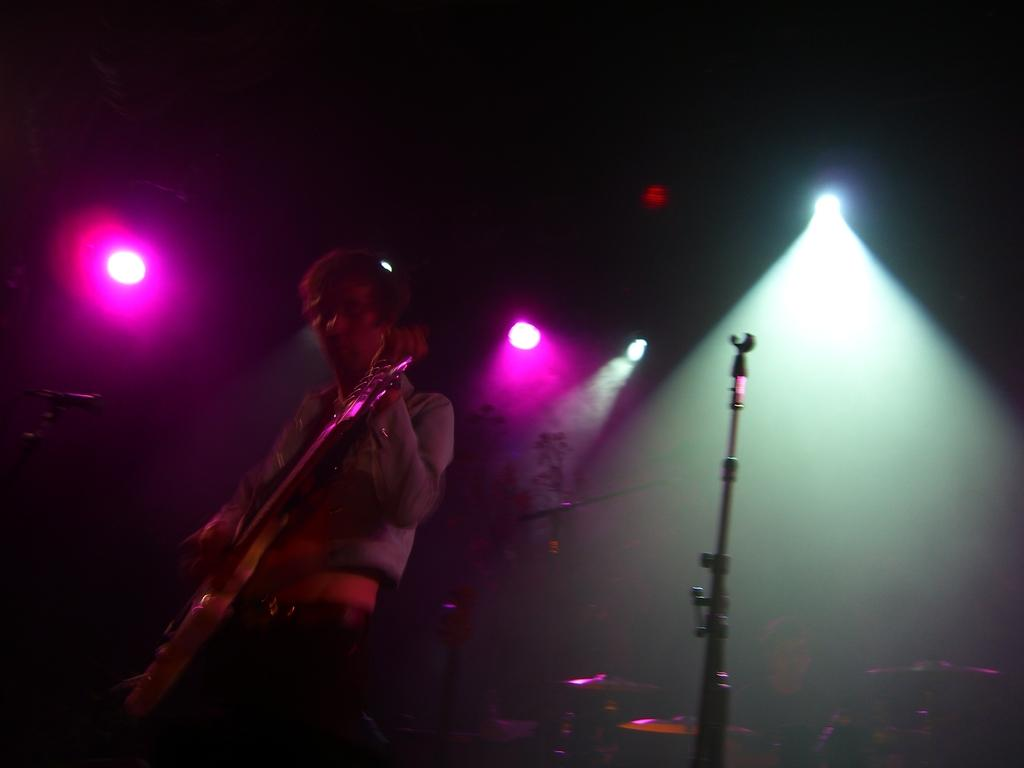What is the person in the image doing? The person in the image is playing a guitar. Where was the image taken? The image was taken at a concert. What can be seen to the right of the person? There is a stand to the right of the person. What can be seen in the background of the image? There are lights visible in the background of the image. How many chairs are visible in the image? There are no chairs visible in the image. What type of wind can be felt in the image? There is no indication of wind in the image, as it is taken indoors at a concert. 